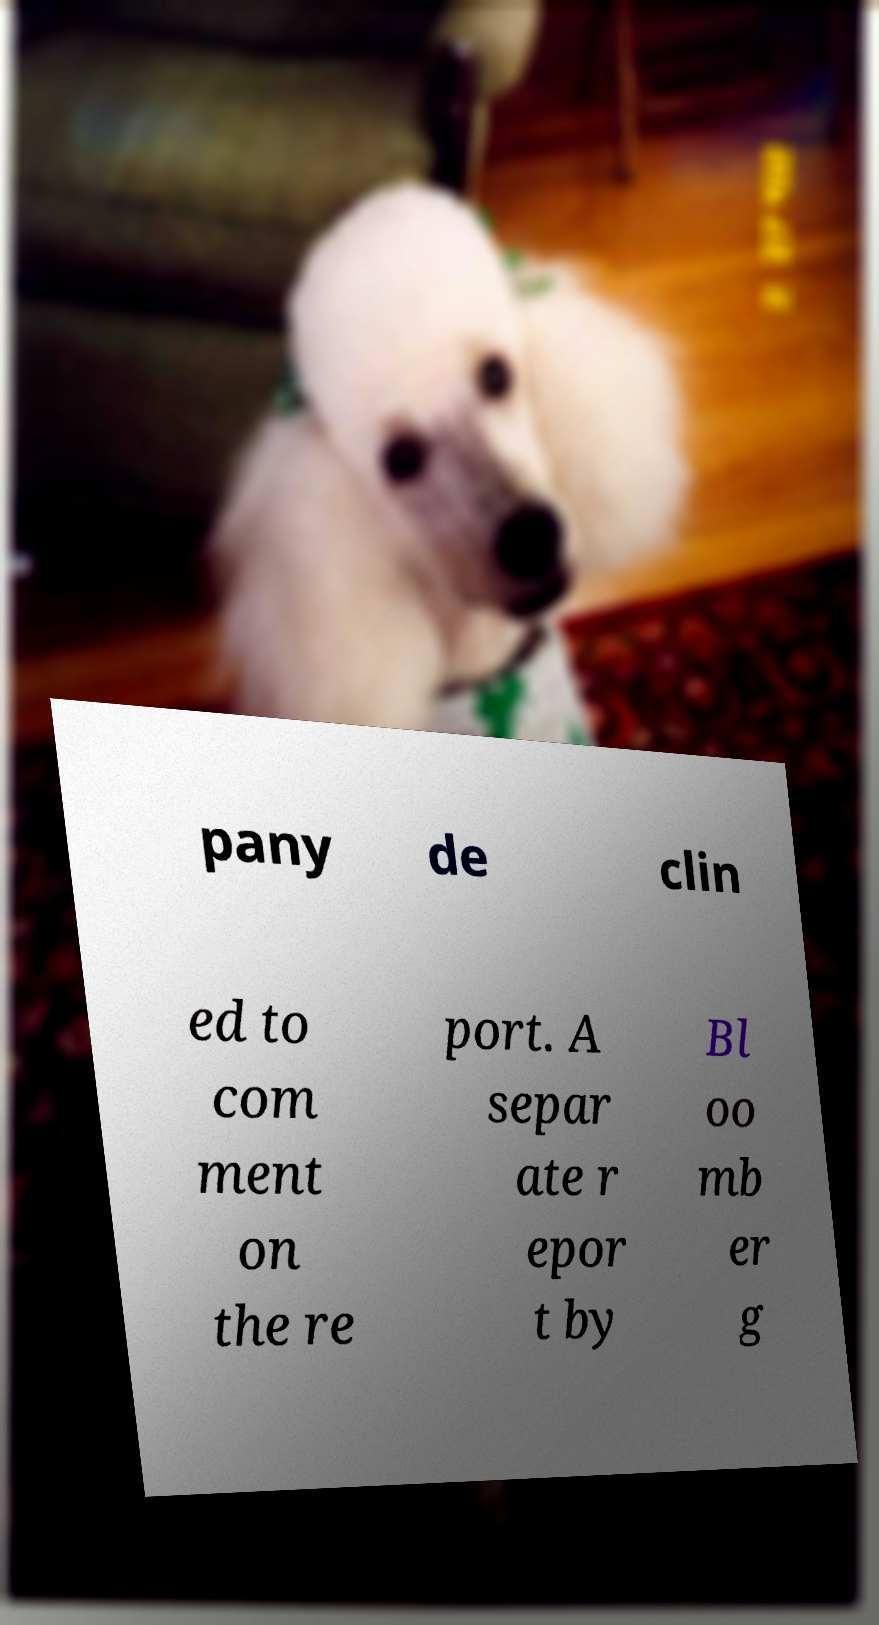Please identify and transcribe the text found in this image. pany de clin ed to com ment on the re port. A separ ate r epor t by Bl oo mb er g 